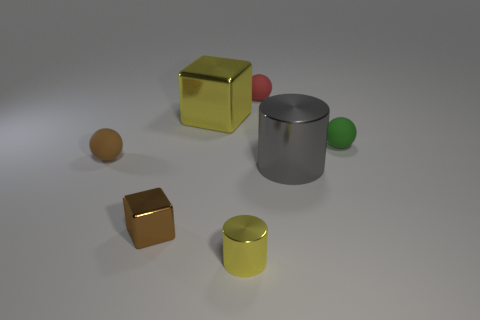Subtract all small red spheres. How many spheres are left? 2 Subtract all green spheres. How many spheres are left? 2 Subtract 2 spheres. How many spheres are left? 1 Add 2 small green things. How many objects exist? 9 Subtract all blocks. How many objects are left? 5 Add 1 big blocks. How many big blocks are left? 2 Add 1 tiny yellow metallic cylinders. How many tiny yellow metallic cylinders exist? 2 Subtract 0 cyan blocks. How many objects are left? 7 Subtract all purple cubes. Subtract all yellow spheres. How many cubes are left? 2 Subtract all brown cylinders. How many brown blocks are left? 1 